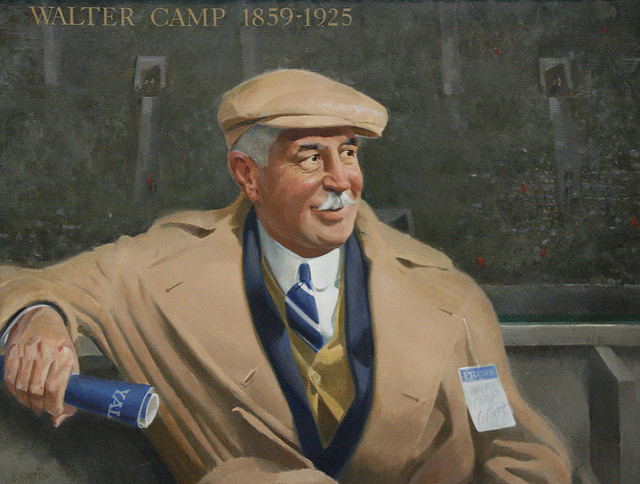Please transcribe the text in this image. WALTER CAMP 1859 19.25 